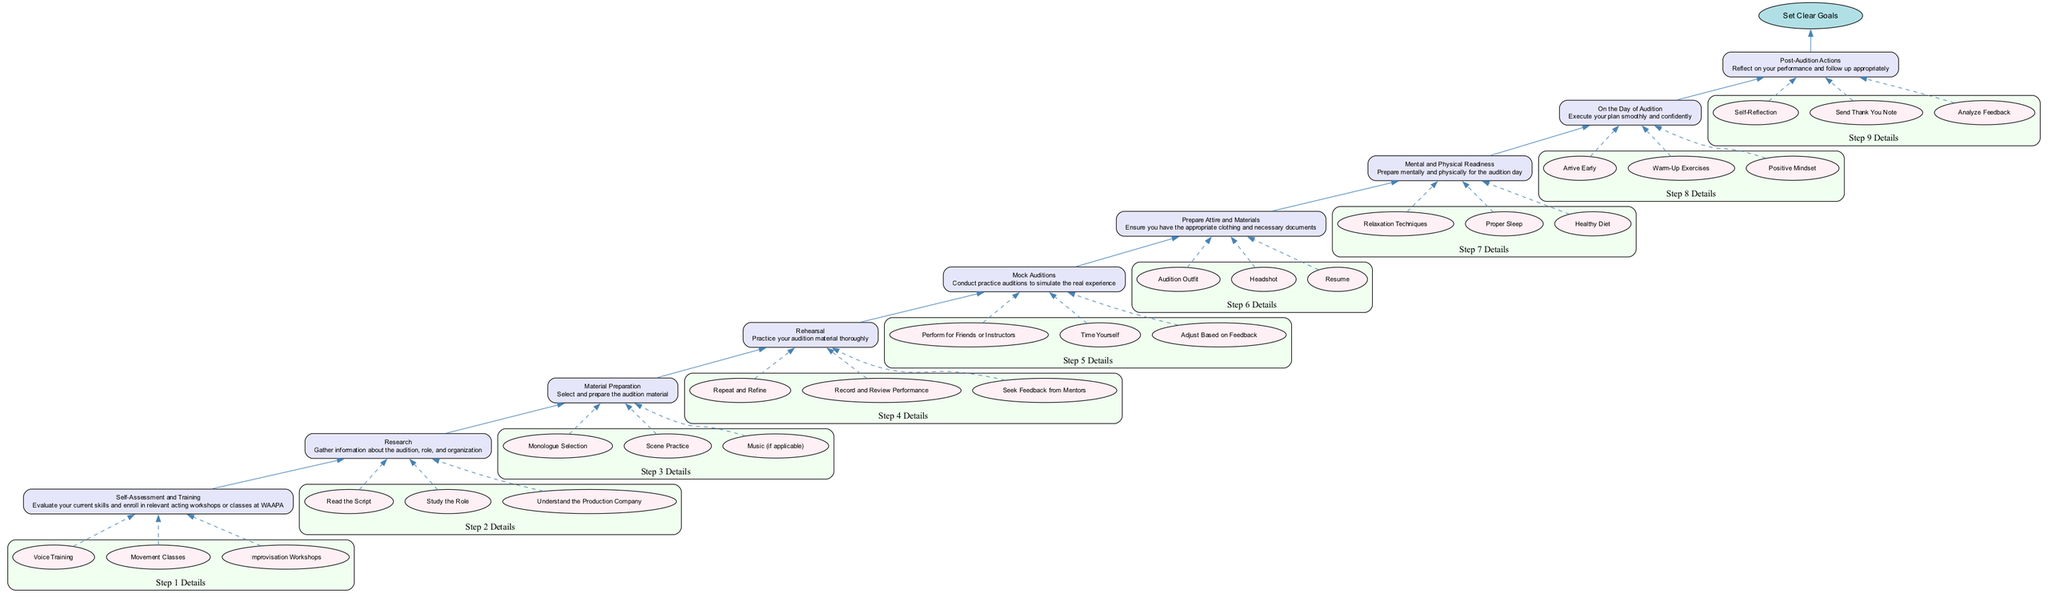What is the base of the flow chart? The base of the flow chart is stated clearly at the top of the diagram, indicating the overarching goal that the preparation process aims to achieve. The base node explicitly labeled is "Set Clear Goals".
Answer: Set Clear Goals How many steps are listed in the diagram? To determine the total number of steps, we can count the individual nodes representing each step in the flow chart. There are eight distinct steps leading up to the base.
Answer: 8 What is the last action to take on the day of audition? Reviewing the steps, the final action related to the audition day is described in the last labeled node where one should maintain a "Positive Mindset" as part of the day’s actions.
Answer: Positive Mindset How does "Mental and Physical Readiness" connect to "Mock Auditions"? By tracing the flow, "Mental and Physical Readiness" is placed above "Mock Auditions" in the diagram, indicating that being prepared mentally and physically occurs before the practice simulations. Thus, the connection is one of progression where readiness is essential before conducting mock auditions.
Answer: Above What are the entities associated with "Self-Assessment and Training"? Each step has associated entities listed within it. For "Self-Assessment and Training", the associated entities that pertain to this step are "Voice Training", "Movement Classes", and "Improvisation Workshops".
Answer: Voice Training, Movement Classes, Improvisation Workshops How many elements connect to the "On the Day of Audition" node? The node labeled "On the Day of Audition" has three specified entities: "Arrive Early", "Warm-Up Exercises", and "Positive Mindset". This signifies that there are three elements directly connected to this specific action related to the audition day.
Answer: 3 What step comes before "Material Preparation"? By following the arrows in the diagram that indicate the flow from previous to next steps, the step that immediately precedes "Material Preparation" is "Research".
Answer: Research Which step involves practicing audition materials thoroughly? Looking at the description of each step, the task that specifically refers to practicing and refining audition materials is explicitly stated in the node labeled "Rehearsal".
Answer: Rehearsal 